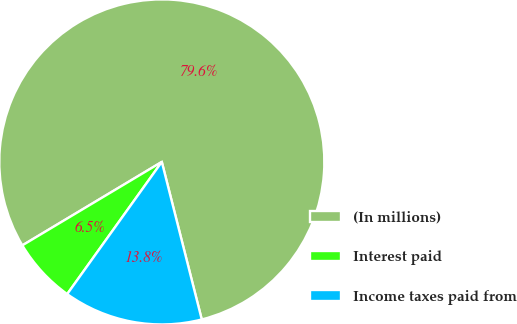Convert chart. <chart><loc_0><loc_0><loc_500><loc_500><pie_chart><fcel>(In millions)<fcel>Interest paid<fcel>Income taxes paid from<nl><fcel>79.63%<fcel>6.53%<fcel>13.84%<nl></chart> 